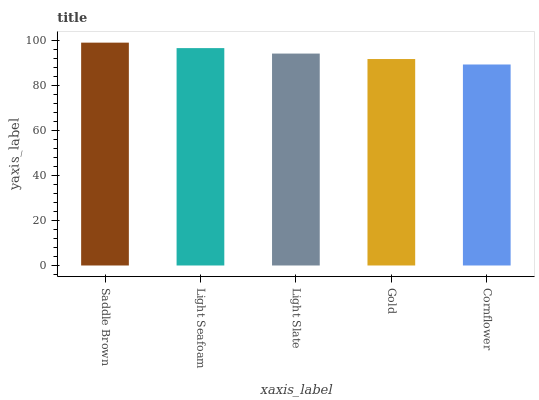Is Cornflower the minimum?
Answer yes or no. Yes. Is Saddle Brown the maximum?
Answer yes or no. Yes. Is Light Seafoam the minimum?
Answer yes or no. No. Is Light Seafoam the maximum?
Answer yes or no. No. Is Saddle Brown greater than Light Seafoam?
Answer yes or no. Yes. Is Light Seafoam less than Saddle Brown?
Answer yes or no. Yes. Is Light Seafoam greater than Saddle Brown?
Answer yes or no. No. Is Saddle Brown less than Light Seafoam?
Answer yes or no. No. Is Light Slate the high median?
Answer yes or no. Yes. Is Light Slate the low median?
Answer yes or no. Yes. Is Saddle Brown the high median?
Answer yes or no. No. Is Saddle Brown the low median?
Answer yes or no. No. 